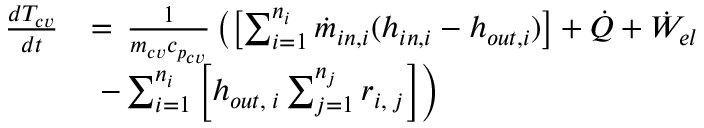<formula> <loc_0><loc_0><loc_500><loc_500>\begin{array} { r l } { \frac { d T _ { c v } } { d t } } & { = \, \frac { 1 } { m _ { c v } c _ { p _ { c v } } } \left ( \left [ \sum _ { i = 1 } ^ { n _ { i } } \ D o t { m } _ { i n , i } ( h _ { i n , i } - h _ { o u t , i } ) \right ] + \ D o t { Q } + \ D o t { W } _ { e l } } \\ & { \, - \sum _ { i = 1 } ^ { n _ { i } } \left [ h _ { o u t , \, i } \sum _ { j = 1 } ^ { n _ { j } } r _ { i , \, j } \right ] \right ) } \end{array}</formula> 